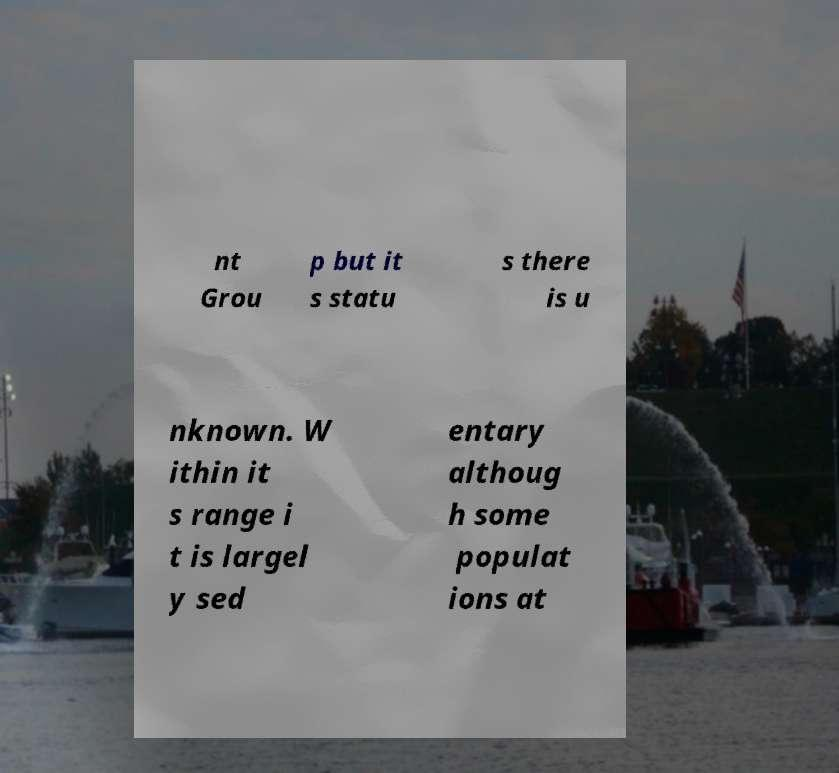For documentation purposes, I need the text within this image transcribed. Could you provide that? nt Grou p but it s statu s there is u nknown. W ithin it s range i t is largel y sed entary althoug h some populat ions at 